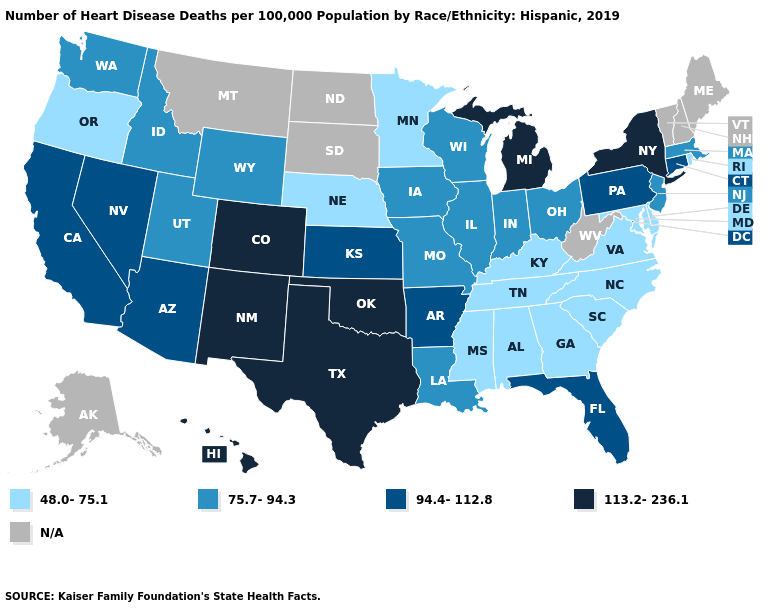What is the lowest value in the USA?
Be succinct. 48.0-75.1. Which states hav the highest value in the Northeast?
Short answer required. New York. Name the states that have a value in the range 48.0-75.1?
Give a very brief answer. Alabama, Delaware, Georgia, Kentucky, Maryland, Minnesota, Mississippi, Nebraska, North Carolina, Oregon, Rhode Island, South Carolina, Tennessee, Virginia. What is the value of Kentucky?
Keep it brief. 48.0-75.1. What is the value of Kentucky?
Be succinct. 48.0-75.1. What is the lowest value in the South?
Give a very brief answer. 48.0-75.1. Name the states that have a value in the range 113.2-236.1?
Give a very brief answer. Colorado, Hawaii, Michigan, New Mexico, New York, Oklahoma, Texas. Does Wyoming have the highest value in the West?
Give a very brief answer. No. Does New York have the highest value in the Northeast?
Keep it brief. Yes. Name the states that have a value in the range 113.2-236.1?
Answer briefly. Colorado, Hawaii, Michigan, New Mexico, New York, Oklahoma, Texas. Name the states that have a value in the range 113.2-236.1?
Keep it brief. Colorado, Hawaii, Michigan, New Mexico, New York, Oklahoma, Texas. Name the states that have a value in the range 113.2-236.1?
Quick response, please. Colorado, Hawaii, Michigan, New Mexico, New York, Oklahoma, Texas. Which states have the lowest value in the USA?
Write a very short answer. Alabama, Delaware, Georgia, Kentucky, Maryland, Minnesota, Mississippi, Nebraska, North Carolina, Oregon, Rhode Island, South Carolina, Tennessee, Virginia. 